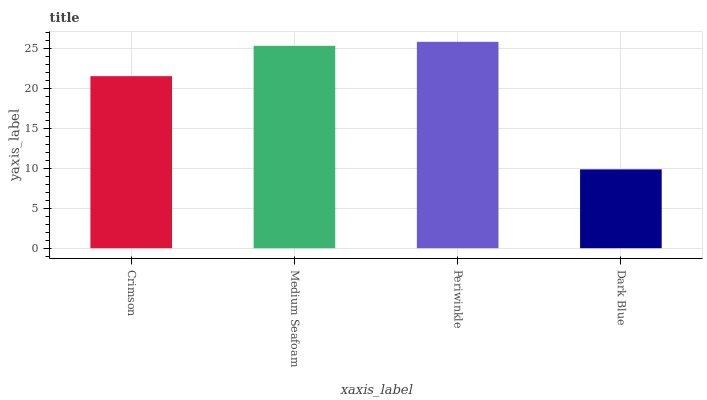Is Dark Blue the minimum?
Answer yes or no. Yes. Is Periwinkle the maximum?
Answer yes or no. Yes. Is Medium Seafoam the minimum?
Answer yes or no. No. Is Medium Seafoam the maximum?
Answer yes or no. No. Is Medium Seafoam greater than Crimson?
Answer yes or no. Yes. Is Crimson less than Medium Seafoam?
Answer yes or no. Yes. Is Crimson greater than Medium Seafoam?
Answer yes or no. No. Is Medium Seafoam less than Crimson?
Answer yes or no. No. Is Medium Seafoam the high median?
Answer yes or no. Yes. Is Crimson the low median?
Answer yes or no. Yes. Is Periwinkle the high median?
Answer yes or no. No. Is Medium Seafoam the low median?
Answer yes or no. No. 